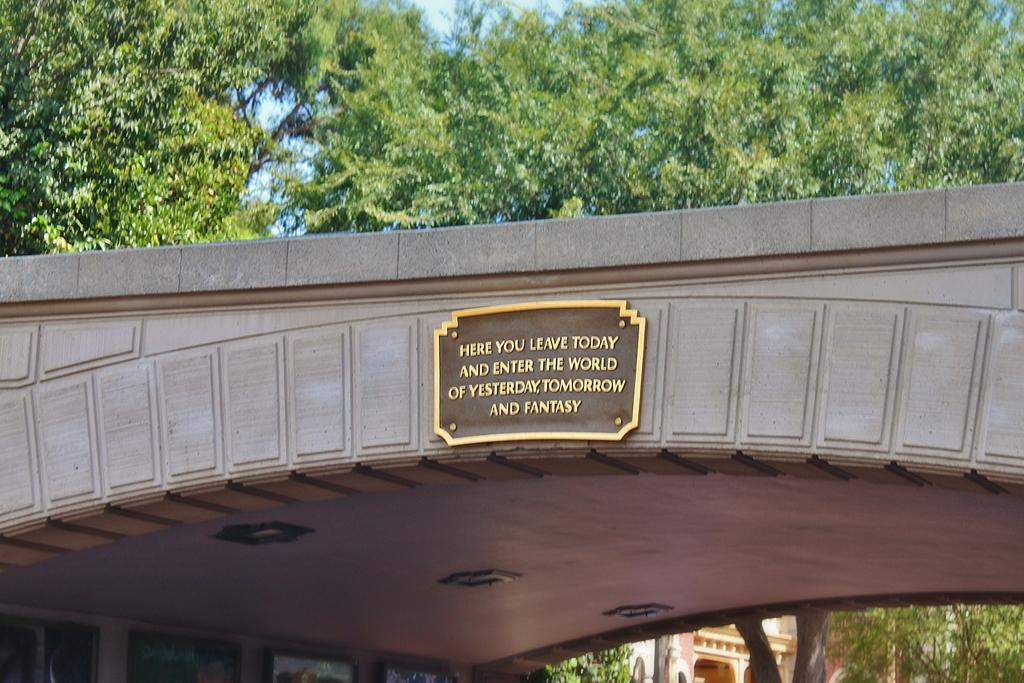Provide a one-sentence caption for the provided image. A plaque on a bridge informs visitors they are entering a world of fantasy. 